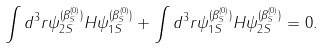<formula> <loc_0><loc_0><loc_500><loc_500>\int d ^ { 3 } r \psi _ { 2 S } ^ { ( \beta _ { S } ^ { ( 0 ) } ) } H \psi _ { 1 S } ^ { ( \beta _ { S } ^ { ( 0 ) } ) } + \int d ^ { 3 } r \psi _ { 1 S } ^ { ( \beta _ { S } ^ { ( 0 ) } ) } H \psi _ { 2 S } ^ { ( \beta _ { S } ^ { ( 0 ) } ) } = 0 .</formula> 